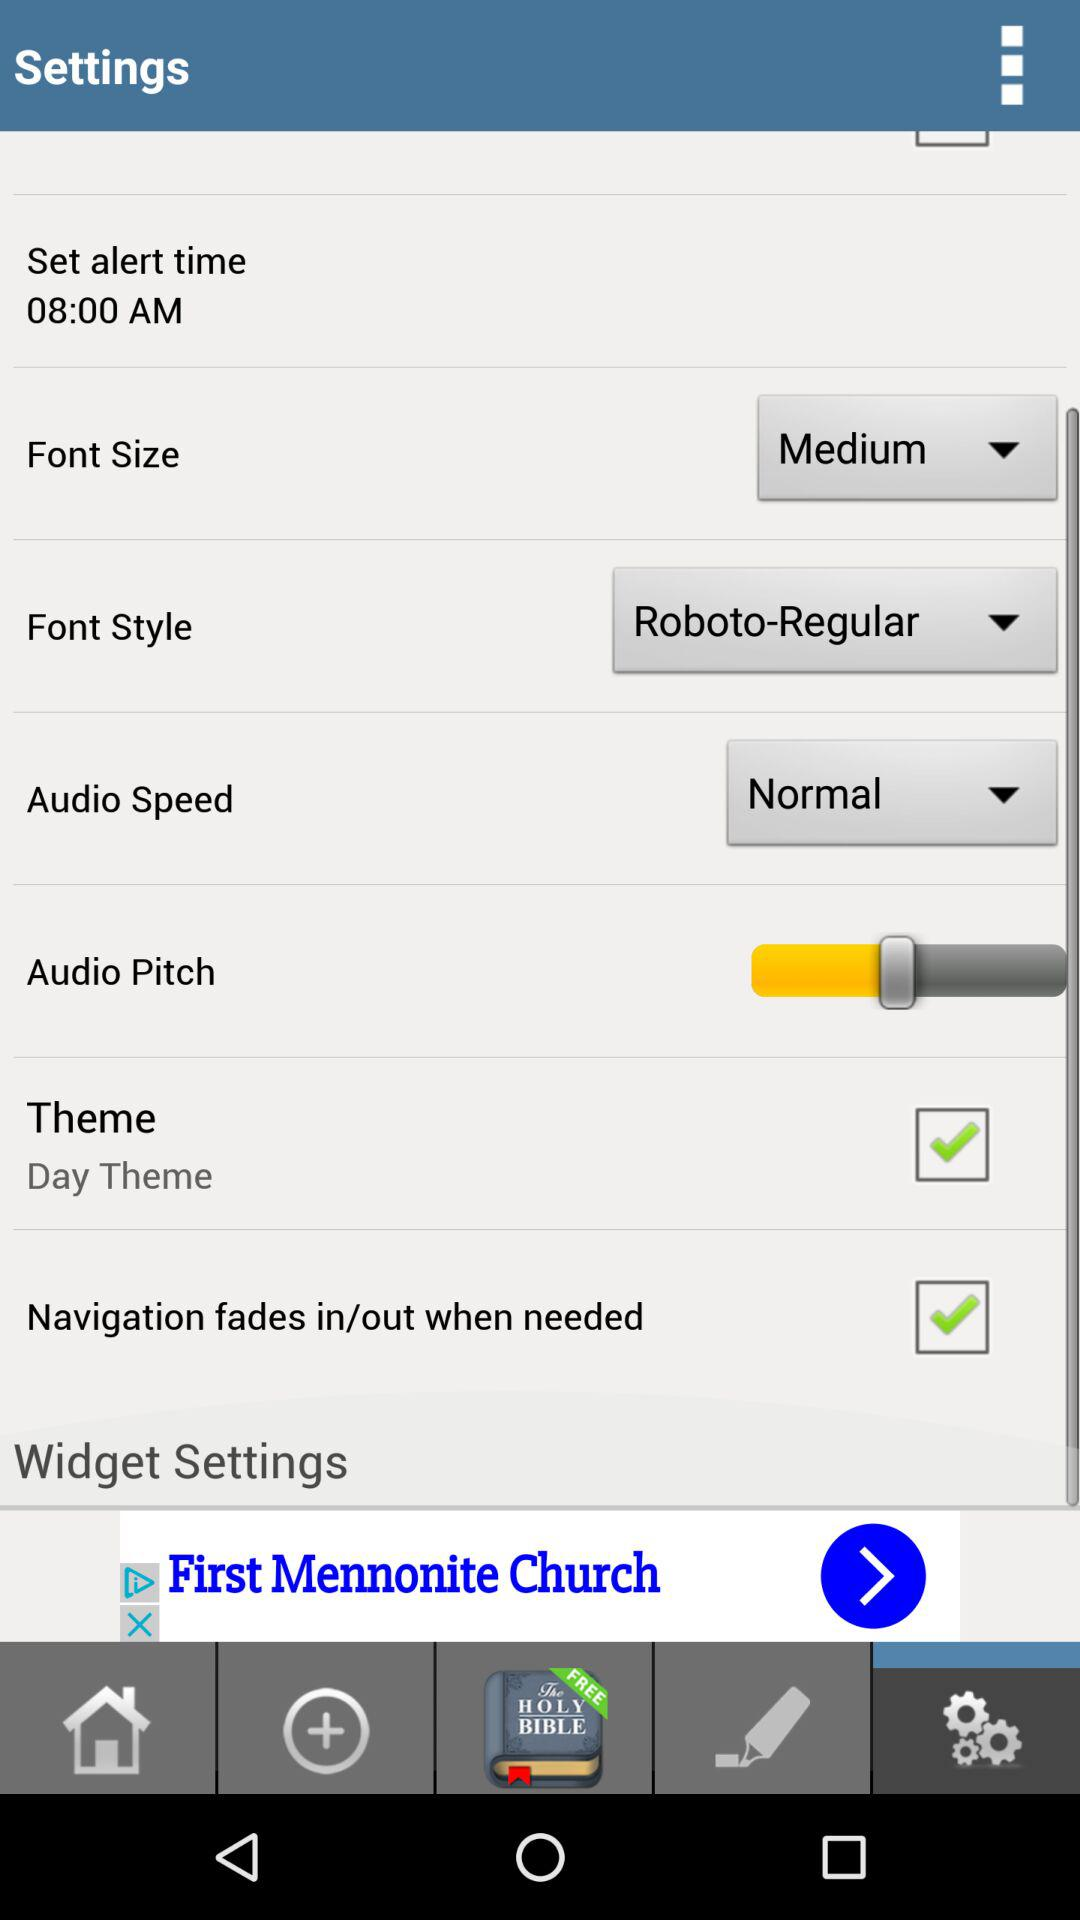What is the alert time? The alert time is 08:00 AM. 